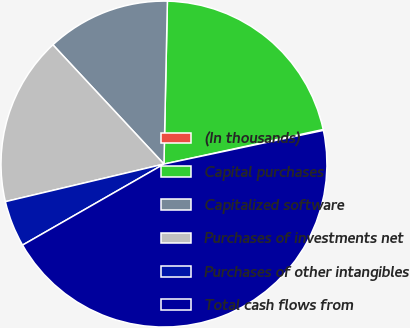Convert chart to OTSL. <chart><loc_0><loc_0><loc_500><loc_500><pie_chart><fcel>(In thousands)<fcel>Capital purchases<fcel>Capitalized software<fcel>Purchases of investments net<fcel>Purchases of other intangibles<fcel>Total cash flows from<nl><fcel>0.09%<fcel>21.26%<fcel>12.27%<fcel>16.77%<fcel>4.58%<fcel>45.03%<nl></chart> 